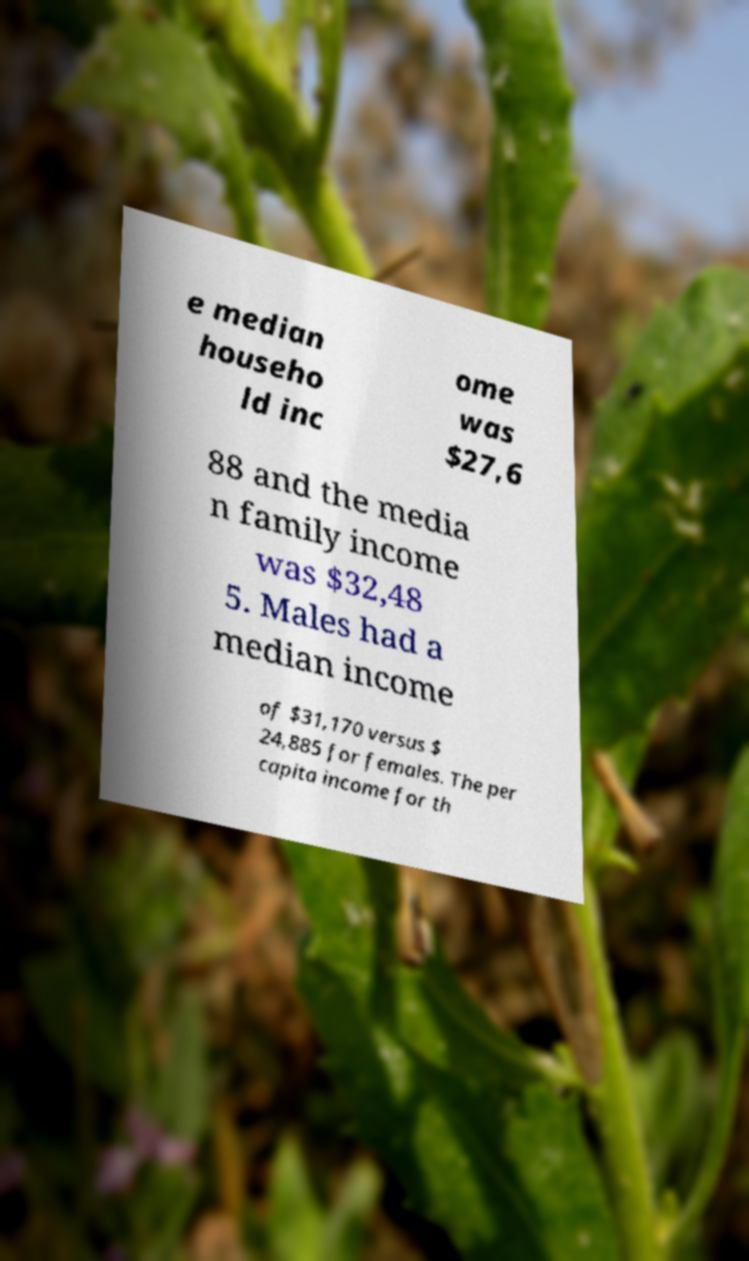I need the written content from this picture converted into text. Can you do that? e median househo ld inc ome was $27,6 88 and the media n family income was $32,48 5. Males had a median income of $31,170 versus $ 24,885 for females. The per capita income for th 